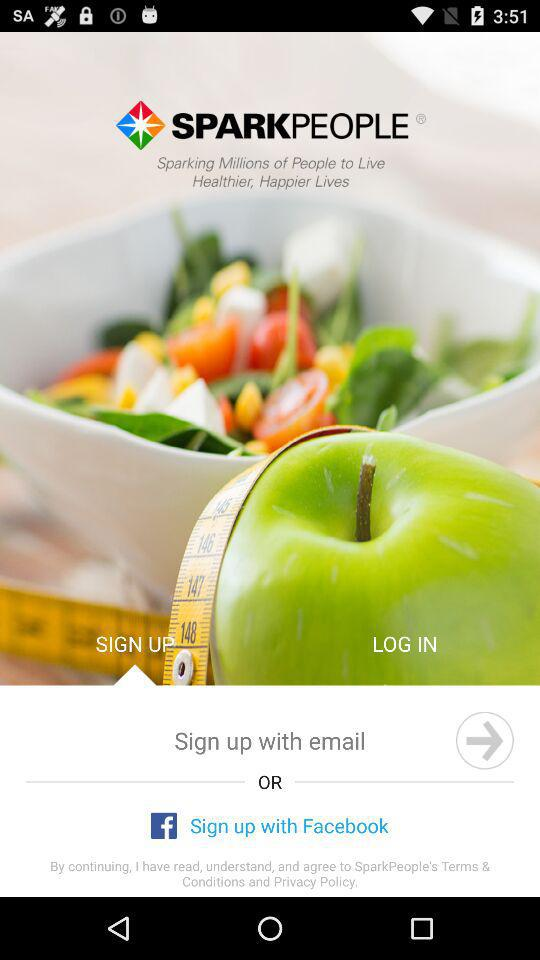What is the name of the application? The name of the application is "SPARK PEOPLE". 